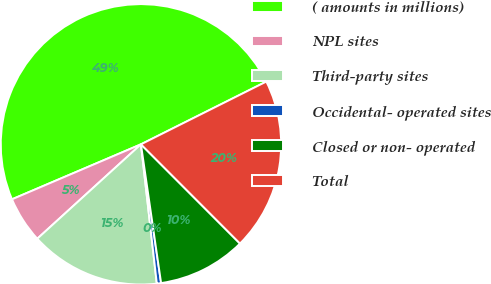<chart> <loc_0><loc_0><loc_500><loc_500><pie_chart><fcel>( amounts in millions)<fcel>NPL sites<fcel>Third-party sites<fcel>Occidental- operated sites<fcel>Closed or non- operated<fcel>Total<nl><fcel>49.03%<fcel>5.34%<fcel>15.05%<fcel>0.49%<fcel>10.19%<fcel>19.9%<nl></chart> 